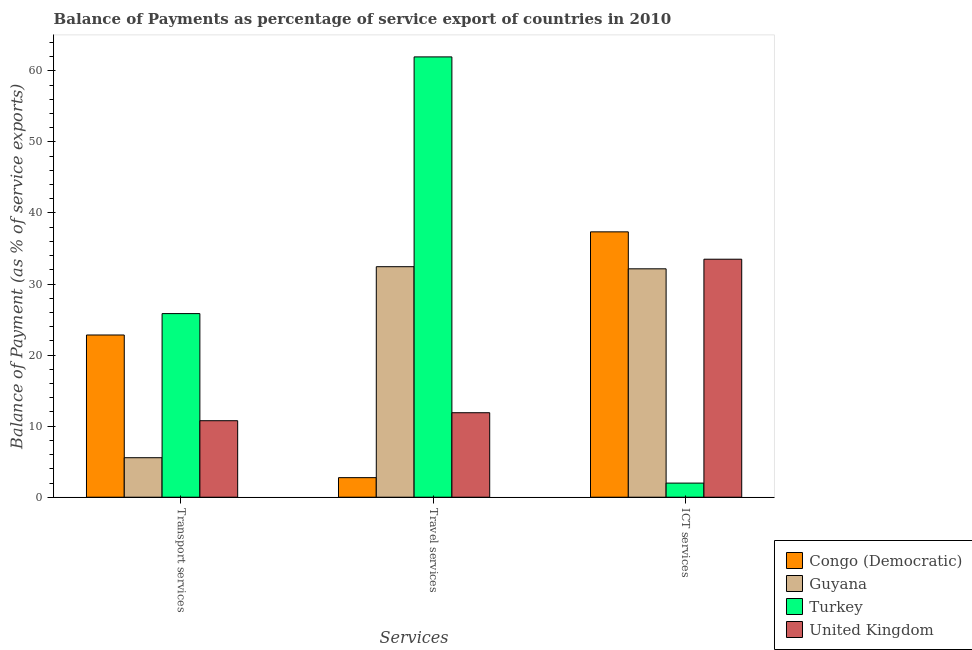How many different coloured bars are there?
Make the answer very short. 4. Are the number of bars per tick equal to the number of legend labels?
Offer a very short reply. Yes. Are the number of bars on each tick of the X-axis equal?
Your answer should be compact. Yes. What is the label of the 3rd group of bars from the left?
Provide a short and direct response. ICT services. What is the balance of payment of travel services in Congo (Democratic)?
Keep it short and to the point. 2.75. Across all countries, what is the maximum balance of payment of ict services?
Make the answer very short. 37.34. Across all countries, what is the minimum balance of payment of ict services?
Offer a very short reply. 1.99. In which country was the balance of payment of travel services maximum?
Your answer should be compact. Turkey. In which country was the balance of payment of transport services minimum?
Give a very brief answer. Guyana. What is the total balance of payment of ict services in the graph?
Keep it short and to the point. 104.95. What is the difference between the balance of payment of transport services in United Kingdom and that in Guyana?
Give a very brief answer. 5.21. What is the difference between the balance of payment of travel services in Guyana and the balance of payment of ict services in Congo (Democratic)?
Your answer should be very brief. -4.9. What is the average balance of payment of transport services per country?
Make the answer very short. 16.25. What is the difference between the balance of payment of ict services and balance of payment of travel services in Turkey?
Offer a very short reply. -59.97. What is the ratio of the balance of payment of ict services in United Kingdom to that in Congo (Democratic)?
Your answer should be compact. 0.9. Is the balance of payment of travel services in Congo (Democratic) less than that in United Kingdom?
Your answer should be very brief. Yes. What is the difference between the highest and the second highest balance of payment of ict services?
Give a very brief answer. 3.85. What is the difference between the highest and the lowest balance of payment of ict services?
Keep it short and to the point. 35.35. What does the 2nd bar from the left in Travel services represents?
Your response must be concise. Guyana. What does the 1st bar from the right in Travel services represents?
Offer a terse response. United Kingdom. How many bars are there?
Keep it short and to the point. 12. How many countries are there in the graph?
Offer a very short reply. 4. What is the difference between two consecutive major ticks on the Y-axis?
Offer a terse response. 10. Does the graph contain any zero values?
Keep it short and to the point. No. Where does the legend appear in the graph?
Your response must be concise. Bottom right. What is the title of the graph?
Your response must be concise. Balance of Payments as percentage of service export of countries in 2010. Does "Lower middle income" appear as one of the legend labels in the graph?
Keep it short and to the point. No. What is the label or title of the X-axis?
Make the answer very short. Services. What is the label or title of the Y-axis?
Offer a very short reply. Balance of Payment (as % of service exports). What is the Balance of Payment (as % of service exports) in Congo (Democratic) in Transport services?
Your answer should be very brief. 22.83. What is the Balance of Payment (as % of service exports) in Guyana in Transport services?
Your answer should be very brief. 5.56. What is the Balance of Payment (as % of service exports) in Turkey in Transport services?
Offer a very short reply. 25.84. What is the Balance of Payment (as % of service exports) of United Kingdom in Transport services?
Give a very brief answer. 10.76. What is the Balance of Payment (as % of service exports) in Congo (Democratic) in Travel services?
Your answer should be very brief. 2.75. What is the Balance of Payment (as % of service exports) of Guyana in Travel services?
Ensure brevity in your answer.  32.44. What is the Balance of Payment (as % of service exports) of Turkey in Travel services?
Give a very brief answer. 61.96. What is the Balance of Payment (as % of service exports) in United Kingdom in Travel services?
Offer a very short reply. 11.89. What is the Balance of Payment (as % of service exports) in Congo (Democratic) in ICT services?
Your answer should be compact. 37.34. What is the Balance of Payment (as % of service exports) in Guyana in ICT services?
Your response must be concise. 32.14. What is the Balance of Payment (as % of service exports) of Turkey in ICT services?
Your response must be concise. 1.99. What is the Balance of Payment (as % of service exports) in United Kingdom in ICT services?
Provide a succinct answer. 33.49. Across all Services, what is the maximum Balance of Payment (as % of service exports) in Congo (Democratic)?
Provide a short and direct response. 37.34. Across all Services, what is the maximum Balance of Payment (as % of service exports) in Guyana?
Offer a very short reply. 32.44. Across all Services, what is the maximum Balance of Payment (as % of service exports) of Turkey?
Provide a succinct answer. 61.96. Across all Services, what is the maximum Balance of Payment (as % of service exports) of United Kingdom?
Your answer should be compact. 33.49. Across all Services, what is the minimum Balance of Payment (as % of service exports) in Congo (Democratic)?
Offer a very short reply. 2.75. Across all Services, what is the minimum Balance of Payment (as % of service exports) of Guyana?
Offer a terse response. 5.56. Across all Services, what is the minimum Balance of Payment (as % of service exports) of Turkey?
Ensure brevity in your answer.  1.99. Across all Services, what is the minimum Balance of Payment (as % of service exports) in United Kingdom?
Your response must be concise. 10.76. What is the total Balance of Payment (as % of service exports) in Congo (Democratic) in the graph?
Provide a short and direct response. 62.92. What is the total Balance of Payment (as % of service exports) in Guyana in the graph?
Provide a short and direct response. 70.13. What is the total Balance of Payment (as % of service exports) in Turkey in the graph?
Keep it short and to the point. 89.78. What is the total Balance of Payment (as % of service exports) of United Kingdom in the graph?
Provide a succinct answer. 56.14. What is the difference between the Balance of Payment (as % of service exports) of Congo (Democratic) in Transport services and that in Travel services?
Provide a short and direct response. 20.07. What is the difference between the Balance of Payment (as % of service exports) in Guyana in Transport services and that in Travel services?
Provide a succinct answer. -26.88. What is the difference between the Balance of Payment (as % of service exports) in Turkey in Transport services and that in Travel services?
Your answer should be compact. -36.12. What is the difference between the Balance of Payment (as % of service exports) of United Kingdom in Transport services and that in Travel services?
Offer a very short reply. -1.12. What is the difference between the Balance of Payment (as % of service exports) of Congo (Democratic) in Transport services and that in ICT services?
Offer a very short reply. -14.51. What is the difference between the Balance of Payment (as % of service exports) in Guyana in Transport services and that in ICT services?
Your answer should be very brief. -26.58. What is the difference between the Balance of Payment (as % of service exports) in Turkey in Transport services and that in ICT services?
Give a very brief answer. 23.85. What is the difference between the Balance of Payment (as % of service exports) of United Kingdom in Transport services and that in ICT services?
Offer a terse response. -22.72. What is the difference between the Balance of Payment (as % of service exports) in Congo (Democratic) in Travel services and that in ICT services?
Offer a terse response. -34.59. What is the difference between the Balance of Payment (as % of service exports) in Guyana in Travel services and that in ICT services?
Offer a very short reply. 0.3. What is the difference between the Balance of Payment (as % of service exports) in Turkey in Travel services and that in ICT services?
Offer a very short reply. 59.97. What is the difference between the Balance of Payment (as % of service exports) of United Kingdom in Travel services and that in ICT services?
Your answer should be very brief. -21.6. What is the difference between the Balance of Payment (as % of service exports) in Congo (Democratic) in Transport services and the Balance of Payment (as % of service exports) in Guyana in Travel services?
Provide a short and direct response. -9.61. What is the difference between the Balance of Payment (as % of service exports) of Congo (Democratic) in Transport services and the Balance of Payment (as % of service exports) of Turkey in Travel services?
Provide a short and direct response. -39.13. What is the difference between the Balance of Payment (as % of service exports) in Congo (Democratic) in Transport services and the Balance of Payment (as % of service exports) in United Kingdom in Travel services?
Your response must be concise. 10.94. What is the difference between the Balance of Payment (as % of service exports) in Guyana in Transport services and the Balance of Payment (as % of service exports) in Turkey in Travel services?
Keep it short and to the point. -56.4. What is the difference between the Balance of Payment (as % of service exports) of Guyana in Transport services and the Balance of Payment (as % of service exports) of United Kingdom in Travel services?
Ensure brevity in your answer.  -6.33. What is the difference between the Balance of Payment (as % of service exports) of Turkey in Transport services and the Balance of Payment (as % of service exports) of United Kingdom in Travel services?
Provide a succinct answer. 13.95. What is the difference between the Balance of Payment (as % of service exports) of Congo (Democratic) in Transport services and the Balance of Payment (as % of service exports) of Guyana in ICT services?
Provide a succinct answer. -9.31. What is the difference between the Balance of Payment (as % of service exports) in Congo (Democratic) in Transport services and the Balance of Payment (as % of service exports) in Turkey in ICT services?
Your answer should be compact. 20.84. What is the difference between the Balance of Payment (as % of service exports) of Congo (Democratic) in Transport services and the Balance of Payment (as % of service exports) of United Kingdom in ICT services?
Keep it short and to the point. -10.66. What is the difference between the Balance of Payment (as % of service exports) of Guyana in Transport services and the Balance of Payment (as % of service exports) of Turkey in ICT services?
Offer a very short reply. 3.57. What is the difference between the Balance of Payment (as % of service exports) of Guyana in Transport services and the Balance of Payment (as % of service exports) of United Kingdom in ICT services?
Provide a short and direct response. -27.93. What is the difference between the Balance of Payment (as % of service exports) of Turkey in Transport services and the Balance of Payment (as % of service exports) of United Kingdom in ICT services?
Your answer should be very brief. -7.65. What is the difference between the Balance of Payment (as % of service exports) in Congo (Democratic) in Travel services and the Balance of Payment (as % of service exports) in Guyana in ICT services?
Provide a succinct answer. -29.38. What is the difference between the Balance of Payment (as % of service exports) of Congo (Democratic) in Travel services and the Balance of Payment (as % of service exports) of Turkey in ICT services?
Ensure brevity in your answer.  0.77. What is the difference between the Balance of Payment (as % of service exports) in Congo (Democratic) in Travel services and the Balance of Payment (as % of service exports) in United Kingdom in ICT services?
Make the answer very short. -30.74. What is the difference between the Balance of Payment (as % of service exports) of Guyana in Travel services and the Balance of Payment (as % of service exports) of Turkey in ICT services?
Provide a short and direct response. 30.45. What is the difference between the Balance of Payment (as % of service exports) of Guyana in Travel services and the Balance of Payment (as % of service exports) of United Kingdom in ICT services?
Your response must be concise. -1.05. What is the difference between the Balance of Payment (as % of service exports) in Turkey in Travel services and the Balance of Payment (as % of service exports) in United Kingdom in ICT services?
Your answer should be compact. 28.47. What is the average Balance of Payment (as % of service exports) of Congo (Democratic) per Services?
Your answer should be compact. 20.97. What is the average Balance of Payment (as % of service exports) in Guyana per Services?
Your answer should be compact. 23.38. What is the average Balance of Payment (as % of service exports) in Turkey per Services?
Offer a very short reply. 29.93. What is the average Balance of Payment (as % of service exports) of United Kingdom per Services?
Your answer should be very brief. 18.71. What is the difference between the Balance of Payment (as % of service exports) in Congo (Democratic) and Balance of Payment (as % of service exports) in Guyana in Transport services?
Your response must be concise. 17.27. What is the difference between the Balance of Payment (as % of service exports) of Congo (Democratic) and Balance of Payment (as % of service exports) of Turkey in Transport services?
Your answer should be very brief. -3.01. What is the difference between the Balance of Payment (as % of service exports) of Congo (Democratic) and Balance of Payment (as % of service exports) of United Kingdom in Transport services?
Offer a very short reply. 12.06. What is the difference between the Balance of Payment (as % of service exports) in Guyana and Balance of Payment (as % of service exports) in Turkey in Transport services?
Make the answer very short. -20.28. What is the difference between the Balance of Payment (as % of service exports) in Guyana and Balance of Payment (as % of service exports) in United Kingdom in Transport services?
Provide a short and direct response. -5.21. What is the difference between the Balance of Payment (as % of service exports) in Turkey and Balance of Payment (as % of service exports) in United Kingdom in Transport services?
Make the answer very short. 15.07. What is the difference between the Balance of Payment (as % of service exports) of Congo (Democratic) and Balance of Payment (as % of service exports) of Guyana in Travel services?
Ensure brevity in your answer.  -29.68. What is the difference between the Balance of Payment (as % of service exports) of Congo (Democratic) and Balance of Payment (as % of service exports) of Turkey in Travel services?
Offer a very short reply. -59.2. What is the difference between the Balance of Payment (as % of service exports) in Congo (Democratic) and Balance of Payment (as % of service exports) in United Kingdom in Travel services?
Keep it short and to the point. -9.14. What is the difference between the Balance of Payment (as % of service exports) of Guyana and Balance of Payment (as % of service exports) of Turkey in Travel services?
Keep it short and to the point. -29.52. What is the difference between the Balance of Payment (as % of service exports) in Guyana and Balance of Payment (as % of service exports) in United Kingdom in Travel services?
Offer a terse response. 20.55. What is the difference between the Balance of Payment (as % of service exports) in Turkey and Balance of Payment (as % of service exports) in United Kingdom in Travel services?
Provide a succinct answer. 50.07. What is the difference between the Balance of Payment (as % of service exports) of Congo (Democratic) and Balance of Payment (as % of service exports) of Guyana in ICT services?
Your answer should be compact. 5.2. What is the difference between the Balance of Payment (as % of service exports) of Congo (Democratic) and Balance of Payment (as % of service exports) of Turkey in ICT services?
Offer a very short reply. 35.35. What is the difference between the Balance of Payment (as % of service exports) in Congo (Democratic) and Balance of Payment (as % of service exports) in United Kingdom in ICT services?
Your answer should be compact. 3.85. What is the difference between the Balance of Payment (as % of service exports) of Guyana and Balance of Payment (as % of service exports) of Turkey in ICT services?
Offer a terse response. 30.15. What is the difference between the Balance of Payment (as % of service exports) in Guyana and Balance of Payment (as % of service exports) in United Kingdom in ICT services?
Your answer should be very brief. -1.35. What is the difference between the Balance of Payment (as % of service exports) in Turkey and Balance of Payment (as % of service exports) in United Kingdom in ICT services?
Give a very brief answer. -31.5. What is the ratio of the Balance of Payment (as % of service exports) in Congo (Democratic) in Transport services to that in Travel services?
Provide a short and direct response. 8.29. What is the ratio of the Balance of Payment (as % of service exports) in Guyana in Transport services to that in Travel services?
Ensure brevity in your answer.  0.17. What is the ratio of the Balance of Payment (as % of service exports) in Turkey in Transport services to that in Travel services?
Your answer should be compact. 0.42. What is the ratio of the Balance of Payment (as % of service exports) in United Kingdom in Transport services to that in Travel services?
Keep it short and to the point. 0.91. What is the ratio of the Balance of Payment (as % of service exports) in Congo (Democratic) in Transport services to that in ICT services?
Offer a very short reply. 0.61. What is the ratio of the Balance of Payment (as % of service exports) in Guyana in Transport services to that in ICT services?
Provide a succinct answer. 0.17. What is the ratio of the Balance of Payment (as % of service exports) of Turkey in Transport services to that in ICT services?
Offer a terse response. 13.01. What is the ratio of the Balance of Payment (as % of service exports) in United Kingdom in Transport services to that in ICT services?
Your answer should be very brief. 0.32. What is the ratio of the Balance of Payment (as % of service exports) in Congo (Democratic) in Travel services to that in ICT services?
Offer a terse response. 0.07. What is the ratio of the Balance of Payment (as % of service exports) in Guyana in Travel services to that in ICT services?
Offer a very short reply. 1.01. What is the ratio of the Balance of Payment (as % of service exports) of Turkey in Travel services to that in ICT services?
Provide a succinct answer. 31.19. What is the ratio of the Balance of Payment (as % of service exports) in United Kingdom in Travel services to that in ICT services?
Give a very brief answer. 0.35. What is the difference between the highest and the second highest Balance of Payment (as % of service exports) in Congo (Democratic)?
Your response must be concise. 14.51. What is the difference between the highest and the second highest Balance of Payment (as % of service exports) of Guyana?
Offer a terse response. 0.3. What is the difference between the highest and the second highest Balance of Payment (as % of service exports) of Turkey?
Your answer should be very brief. 36.12. What is the difference between the highest and the second highest Balance of Payment (as % of service exports) in United Kingdom?
Provide a succinct answer. 21.6. What is the difference between the highest and the lowest Balance of Payment (as % of service exports) of Congo (Democratic)?
Your answer should be very brief. 34.59. What is the difference between the highest and the lowest Balance of Payment (as % of service exports) of Guyana?
Offer a very short reply. 26.88. What is the difference between the highest and the lowest Balance of Payment (as % of service exports) in Turkey?
Provide a short and direct response. 59.97. What is the difference between the highest and the lowest Balance of Payment (as % of service exports) of United Kingdom?
Provide a short and direct response. 22.72. 